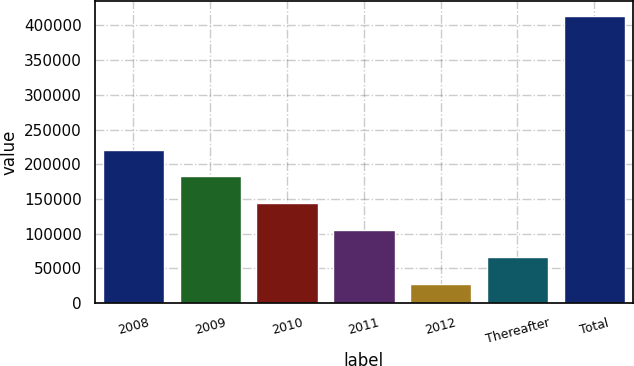<chart> <loc_0><loc_0><loc_500><loc_500><bar_chart><fcel>2008<fcel>2009<fcel>2010<fcel>2011<fcel>2012<fcel>Thereafter<fcel>Total<nl><fcel>221192<fcel>182626<fcel>144060<fcel>105493<fcel>28360<fcel>66926.5<fcel>414025<nl></chart> 